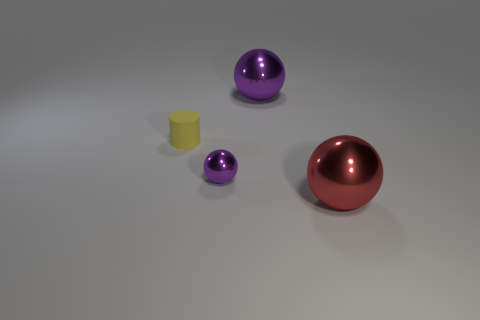What size is the other ball that is the same color as the small shiny sphere?
Offer a terse response. Large. Are there any purple metal objects right of the purple object that is left of the big object on the left side of the red ball?
Your answer should be compact. Yes. Are there fewer small yellow balls than matte cylinders?
Your answer should be compact. Yes. Do the ball behind the cylinder and the yellow thing left of the big purple metal object have the same material?
Offer a terse response. No. Are there fewer small metal objects that are to the left of the small purple metallic ball than large metallic spheres?
Your answer should be compact. Yes. How many yellow objects are in front of the metal sphere in front of the tiny purple metal object?
Give a very brief answer. 0. There is a object that is left of the large purple metal object and in front of the yellow cylinder; what is its size?
Your response must be concise. Small. Are there any other things that have the same material as the yellow cylinder?
Offer a terse response. No. Does the tiny ball have the same material as the big red sphere that is in front of the small purple shiny sphere?
Make the answer very short. Yes. Is the number of big metallic things in front of the tiny yellow rubber object less than the number of metal things that are right of the tiny metallic thing?
Your answer should be very brief. Yes. 